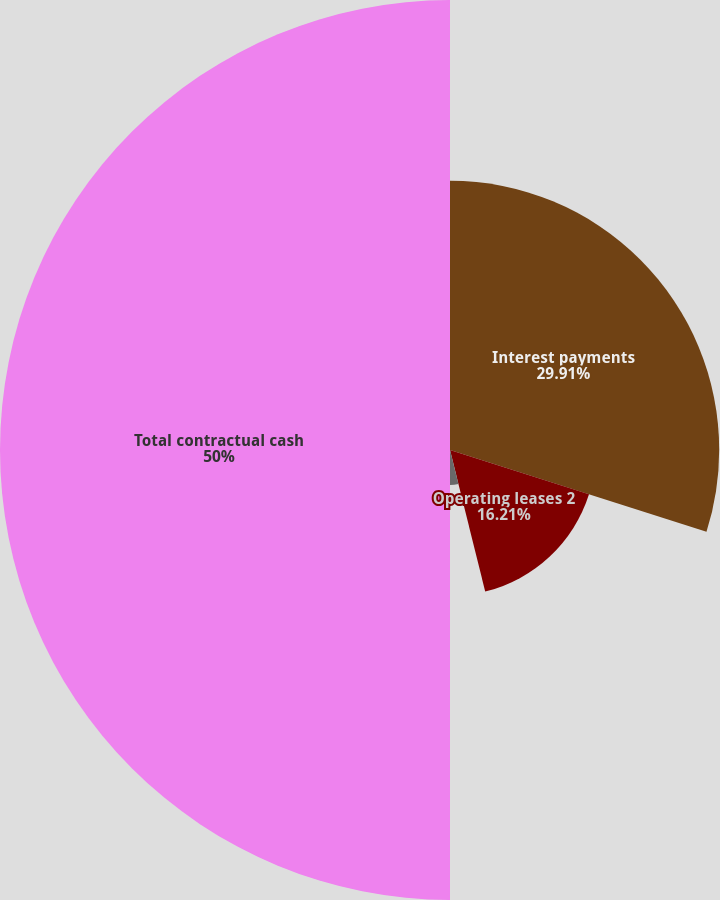Convert chart. <chart><loc_0><loc_0><loc_500><loc_500><pie_chart><fcel>Interest payments<fcel>Operating leases 2<fcel>Purchase obligations and other<fcel>Total contractual cash<nl><fcel>29.91%<fcel>16.21%<fcel>3.88%<fcel>50.0%<nl></chart> 